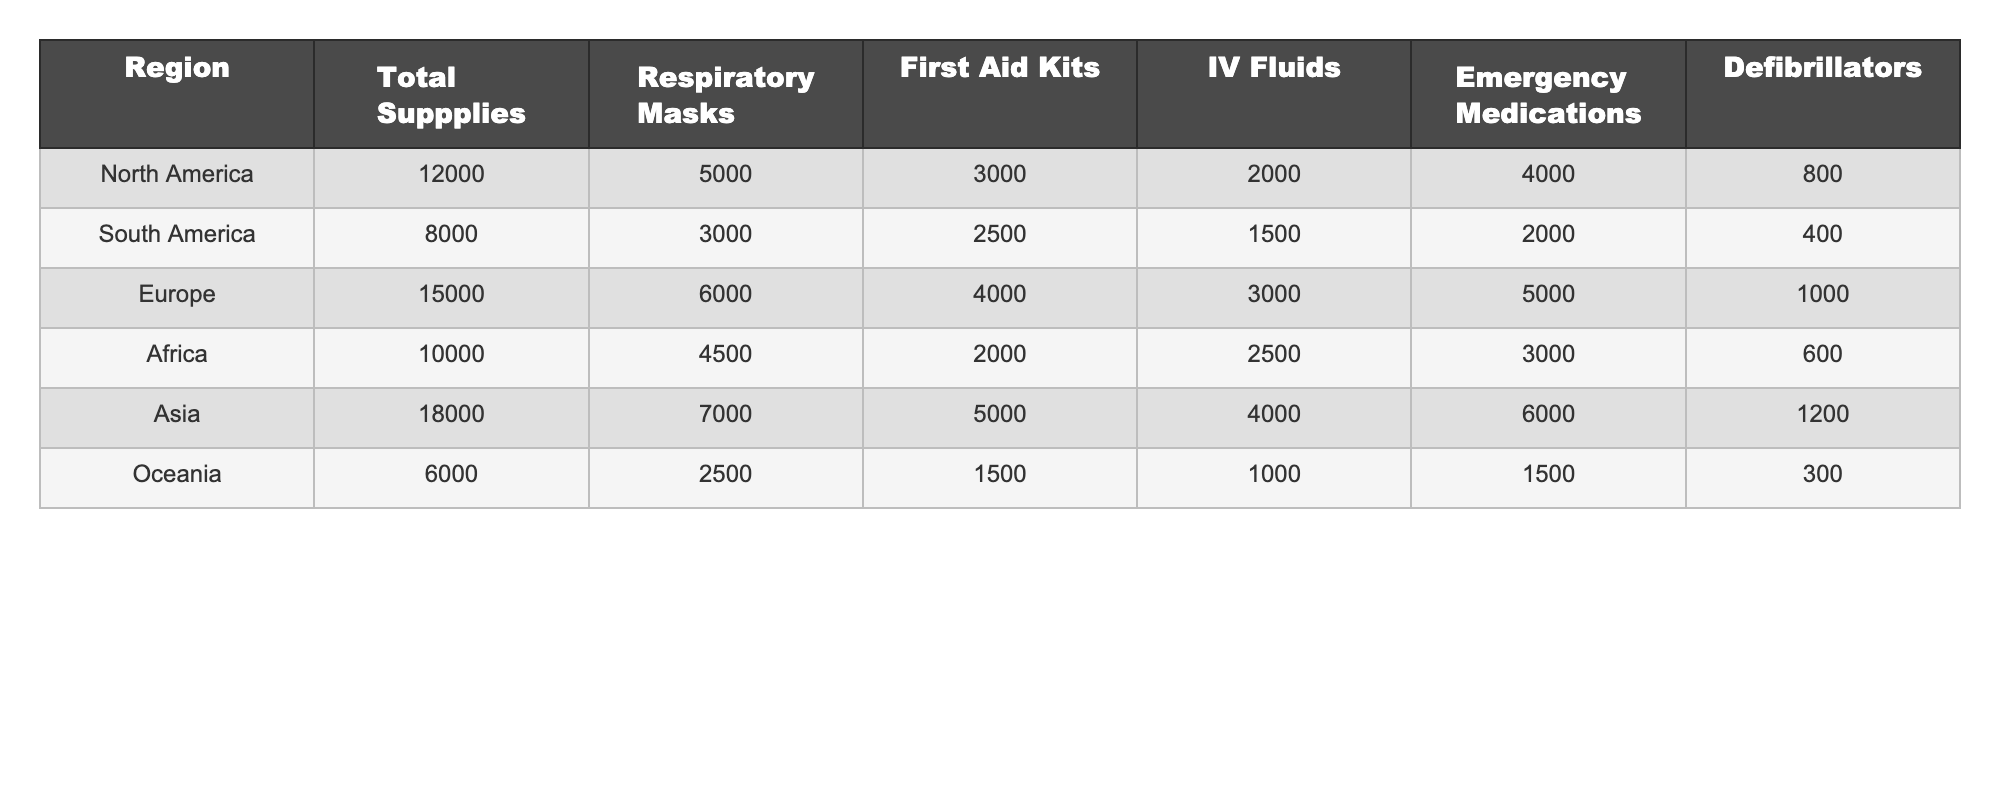What is the total number of emergency medications supplied in Asia? The table states that the total for Emergency Medications in Asia is 6000.
Answer: 6000 Which region has the highest number of first aid kits? By examining the table, it shows that Europe has the highest total for First Aid Kits with 4000.
Answer: Europe How many total supplies are available in South America? The table lists the total supplies in South America as 8000.
Answer: 8000 What is the difference in the number of respiratory masks between Africa and North America? Africa has 4500 respiratory masks while North America has 5000; therefore, the difference is 5000 - 4500 = 500.
Answer: 500 Calculate the average number of defibrillators across all regions. To find the average, add the total defibrillators from each region: 800 + 400 + 1000 + 600 + 1200 + 300 = 3300. There are 6 regions, so the average is 3300 / 6 = 550.
Answer: 550 Is the total number of supplies in Europe greater than that in Asia? Europe has 15000 total supplies and Asia has 18000; since 15000 is not greater than 18000, the statement is false.
Answer: No Which region has the lowest number of IV Fluids? The table indicates that Oceania has the lowest number of IV Fluids at 1000.
Answer: Oceania How many emergency medications are provided in North America compared to South America? North America provides 4000 emergency medications while South America provides 2000; therefore, North America has 4000 - 2000 = 2000 more emergency medications than South America.
Answer: 2000 What is the total number of supplies of all regions combined? By adding all total supplies: 12000 + 8000 + 15000 + 10000 + 18000 + 6000 = 61000.
Answer: 61000 Which region has more than 6000 respiratory masks? The table shows that both Asia and Europe have more than 6000 respiratory masks, with Asia having 7000 and Europe having 6000.
Answer: Asia and Europe 